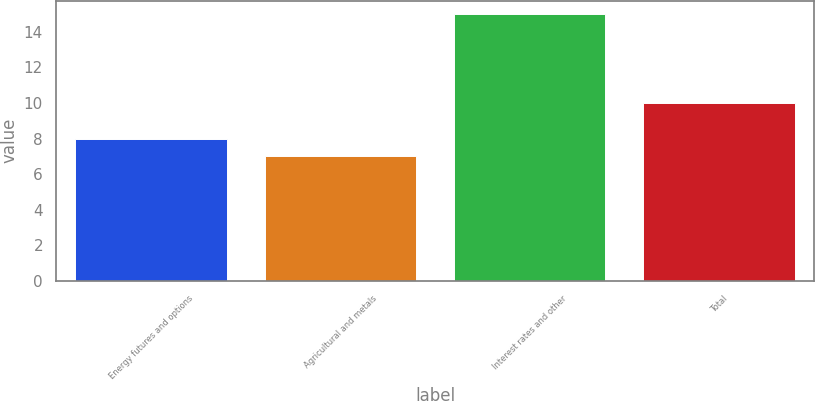<chart> <loc_0><loc_0><loc_500><loc_500><bar_chart><fcel>Energy futures and options<fcel>Agricultural and metals<fcel>Interest rates and other<fcel>Total<nl><fcel>8<fcel>7<fcel>15<fcel>10<nl></chart> 